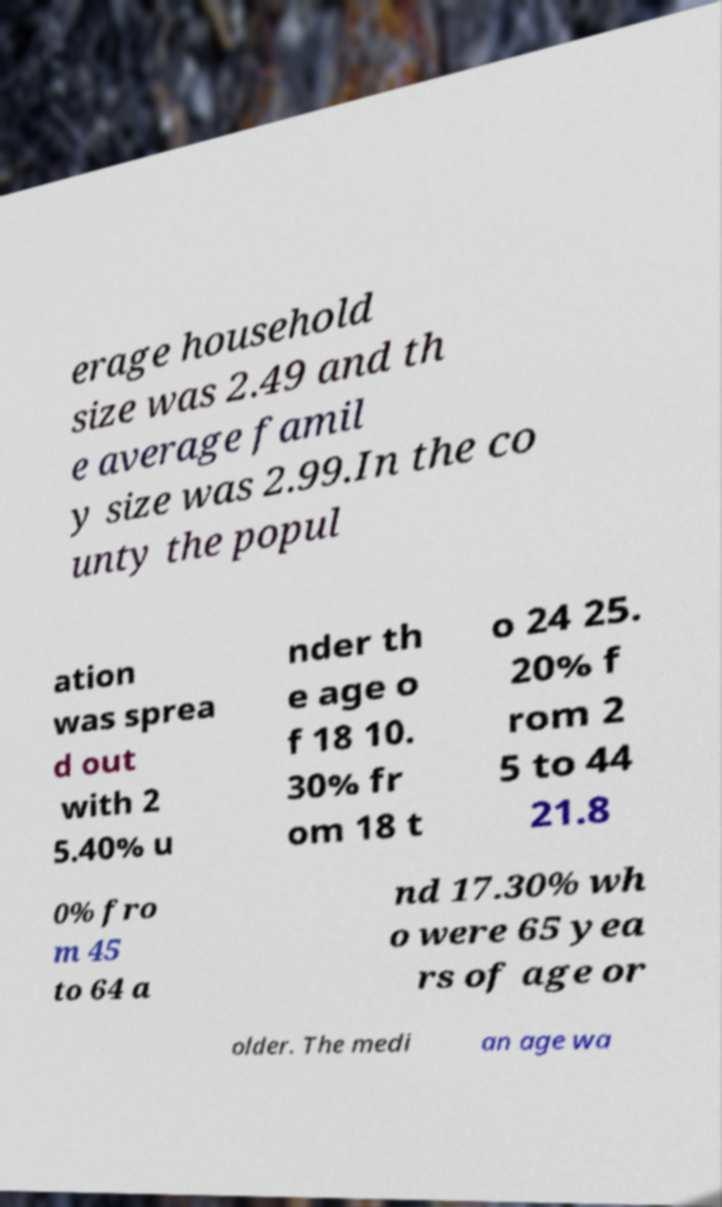There's text embedded in this image that I need extracted. Can you transcribe it verbatim? erage household size was 2.49 and th e average famil y size was 2.99.In the co unty the popul ation was sprea d out with 2 5.40% u nder th e age o f 18 10. 30% fr om 18 t o 24 25. 20% f rom 2 5 to 44 21.8 0% fro m 45 to 64 a nd 17.30% wh o were 65 yea rs of age or older. The medi an age wa 